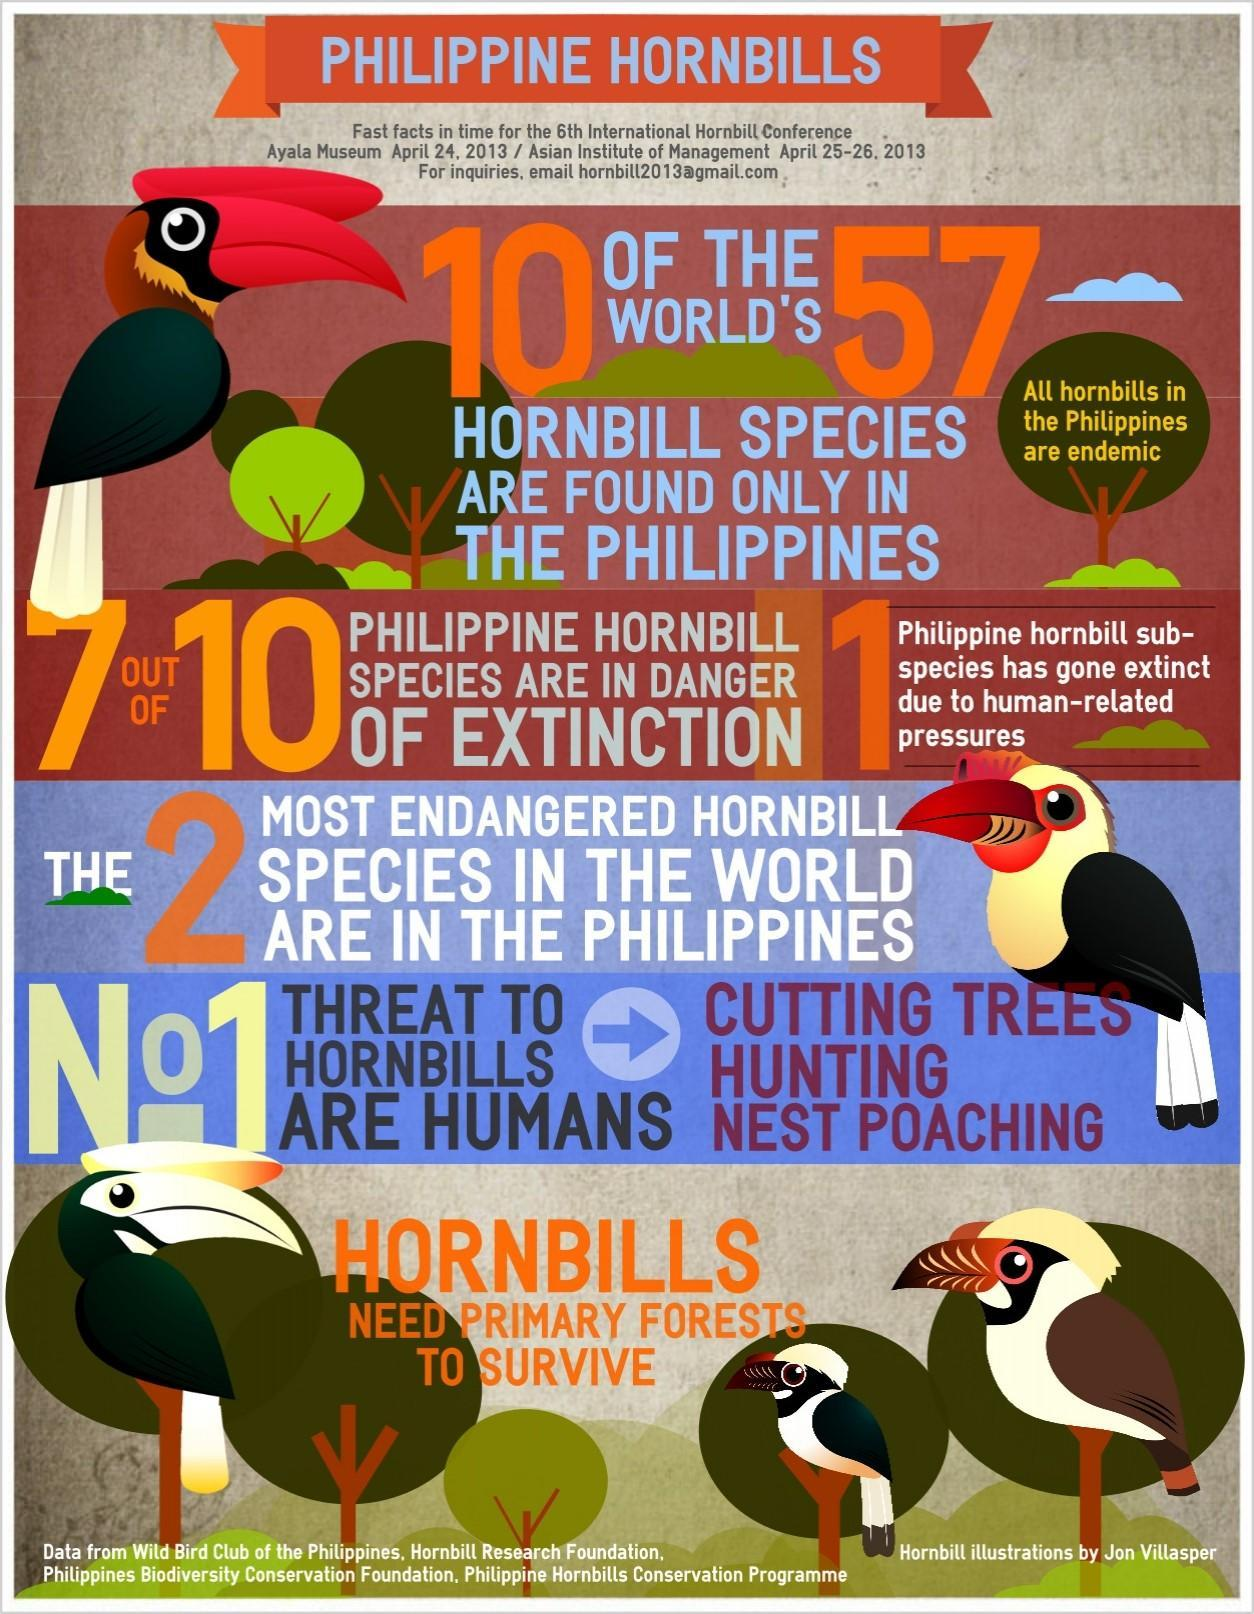How many hornbill images are in this infographic?
Answer the question with a short phrase. 5 Out of 10, how many Philippine hornbill species are not in danger of extinction? 3 Out of 57, how many hornbill species not found in the Philippines? 47 